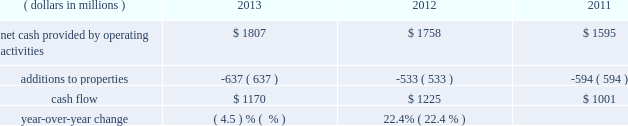General market conditions affecting trust asset performance , future discount rates based on average yields of high quality corporate bonds and our decisions regarding certain elective provisions of the we currently project that we will make total u.s .
And foreign benefit plan contributions in 2014 of approximately $ 57 million .
Actual 2014 contributions could be different from our current projections , as influenced by our decision to undertake discretionary funding of our benefit trusts versus other competing investment priorities , future changes in government requirements , trust asset performance , renewals of union contracts , or higher-than-expected health care claims cost experience .
We measure cash flow as net cash provided by operating activities reduced by expenditures for property additions .
We use this non-gaap financial measure of cash flow to focus management and investors on the amount of cash available for debt repayment , dividend distributions , acquisition opportunities , and share repurchases .
Our cash flow metric is reconciled to the most comparable gaap measure , as follows: .
Year-over-year change ( 4.5 ) % (  % ) 22.4% ( 22.4 % ) the decrease in cash flow ( as defined ) in 2013 compared to 2012 was due primarily to higher capital expenditures .
The increase in cash flow in 2012 compared to 2011 was driven by improved performance in working capital resulting from the one-time benefit derived from the pringles acquisition , as well as changes in the level of capital expenditures during the three-year period .
Investing activities our net cash used in investing activities for 2013 amounted to $ 641 million , a decrease of $ 2604 million compared with 2012 primarily attributable to the $ 2668 million acquisition of pringles in 2012 .
Capital spending in 2013 included investments in our supply chain infrastructure , and to support capacity requirements in certain markets , including pringles .
In addition , we continued the investment in our information technology infrastructure related to the reimplementation and upgrade of our sap platform .
Net cash used in investing activities of $ 3245 million in 2012 increased by $ 2658 million compared with 2011 , due to the acquisition of pringles in 2012 .
Cash paid for additions to properties as a percentage of net sales has increased to 4.3% ( 4.3 % ) in 2013 , from 3.8% ( 3.8 % ) in 2012 , which was a decrease from 4.5% ( 4.5 % ) in financing activities our net cash used by financing activities was $ 1141 million for 2013 , compared to net cash provided by financing activities of $ 1317 million for 2012 and net cash used in financing activities of $ 957 million for 2011 .
The increase in cash provided from financing activities in 2012 compared to 2013 and 2011 , was primarily due to the issuance of debt related to the acquisition of pringles .
Total debt was $ 7.4 billion at year-end 2013 and $ 7.9 billion at year-end 2012 .
In february 2013 , we issued $ 250 million of two-year floating-rate u.s .
Dollar notes , and $ 400 million of ten-year 2.75% ( 2.75 % ) u.s .
Dollar notes , resulting in aggregate net proceeds after debt discount of $ 645 million .
The proceeds from these notes were used for general corporate purposes , including , together with cash on hand , repayment of the $ 750 million aggregate principal amount of our 4.25% ( 4.25 % ) u.s .
Dollar notes due march 2013 .
In may 2012 , we issued $ 350 million of three-year 1.125% ( 1.125 % ) u.s .
Dollar notes , $ 400 million of five-year 1.75% ( 1.75 % ) u.s .
Dollar notes and $ 700 million of ten-year 3.125% ( 3.125 % ) u.s .
Dollar notes , resulting in aggregate net proceeds after debt discount of $ 1.442 billion .
The proceeds of these notes were used for general corporate purposes , including financing a portion of the acquisition of pringles .
In may 2012 , we issued cdn .
$ 300 million of two-year 2.10% ( 2.10 % ) fixed rate canadian dollar notes , using the proceeds from these notes for general corporate purposes , which included repayment of intercompany debt .
This repayment resulted in cash available to be used for a portion of the acquisition of pringles .
In december 2012 , we repaid $ 750 million five-year 5.125% ( 5.125 % ) u.s .
Dollar notes at maturity with commercial paper .
In april 2011 , we repaid $ 945 million ten-year 6.60% ( 6.60 % ) u.s .
Dollar notes at maturity with commercial paper .
In may 2011 , we issued $ 400 million of seven-year 3.25% ( 3.25 % ) fixed rate u.s .
Dollar notes , using the proceeds of $ 397 million for general corporate purposes and repayment of commercial paper .
In november 2011 , we issued $ 500 million of five-year 1.875% ( 1.875 % ) fixed rate u .
Dollar notes , using the proceeds of $ 498 million for general corporate purposes and repayment of commercial paper. .
By what percent did cash provided by operations increase between 2011 and 2013? 
Computations: ((1807 - 1595) / 1595)
Answer: 0.13292. 